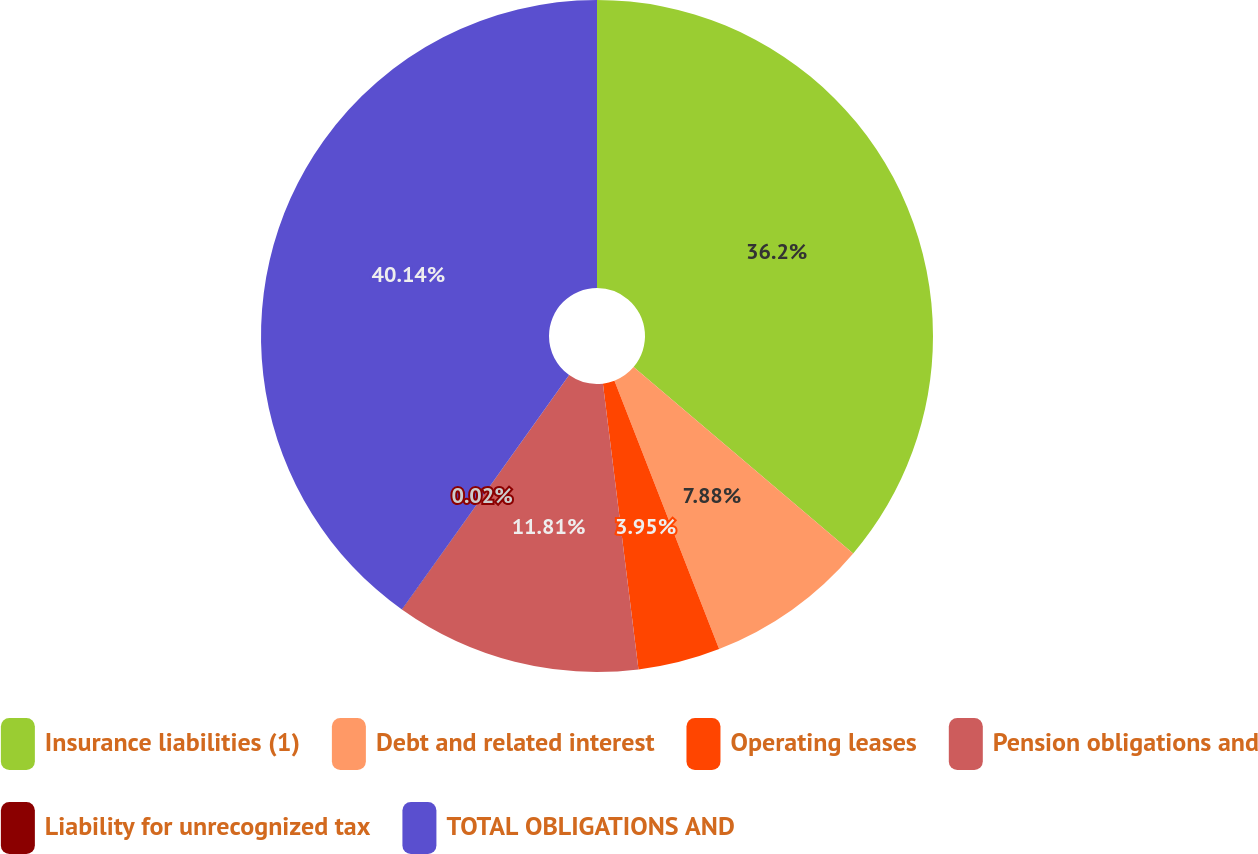Convert chart. <chart><loc_0><loc_0><loc_500><loc_500><pie_chart><fcel>Insurance liabilities (1)<fcel>Debt and related interest<fcel>Operating leases<fcel>Pension obligations and<fcel>Liability for unrecognized tax<fcel>TOTAL OBLIGATIONS AND<nl><fcel>36.2%<fcel>7.88%<fcel>3.95%<fcel>11.81%<fcel>0.02%<fcel>40.14%<nl></chart> 